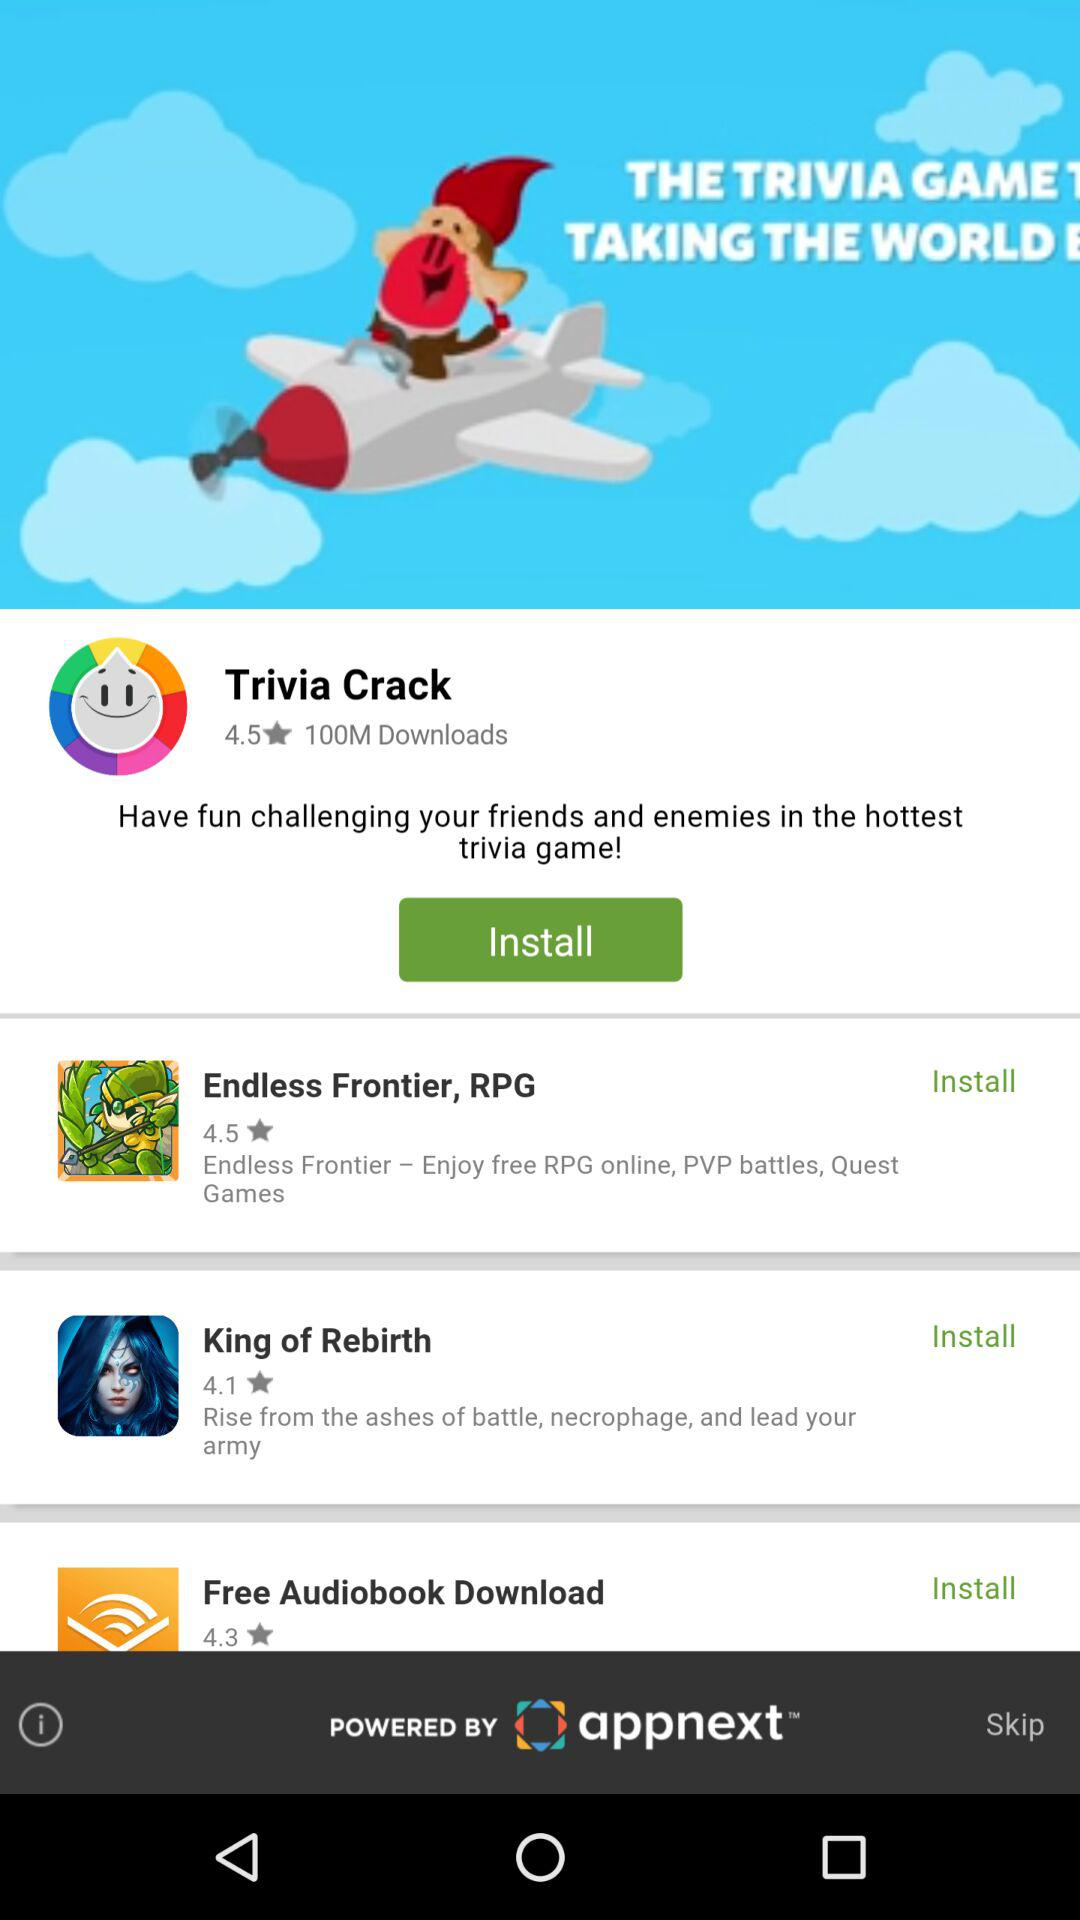What is the rating of "King of Rebirth"? The rating of "King of Rebirth" is 4.1. 